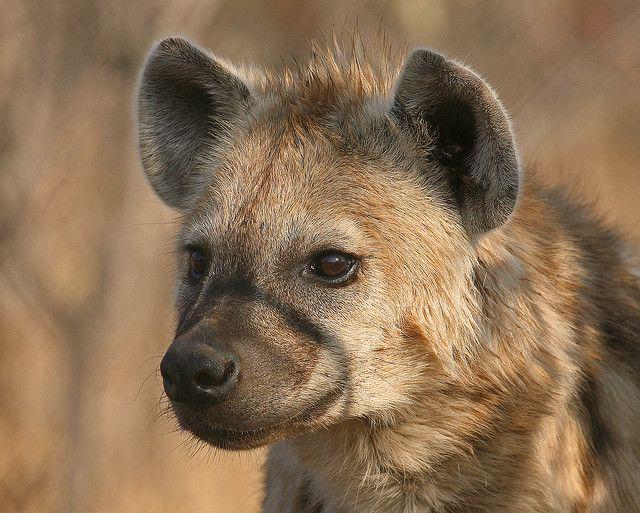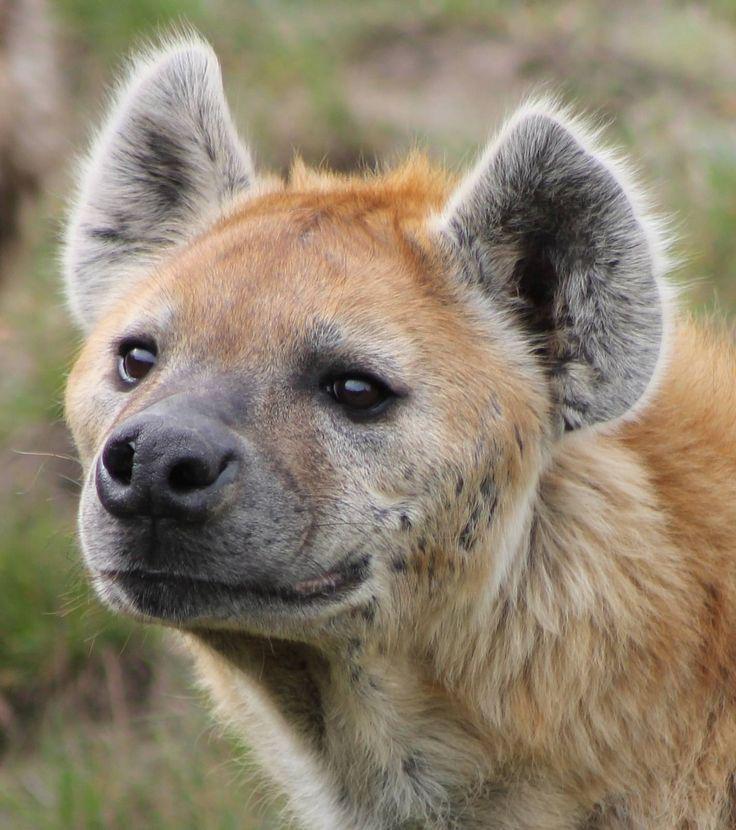The first image is the image on the left, the second image is the image on the right. Examine the images to the left and right. Is the description "The body of the hyena on the left image is facing left" accurate? Answer yes or no. Yes. 